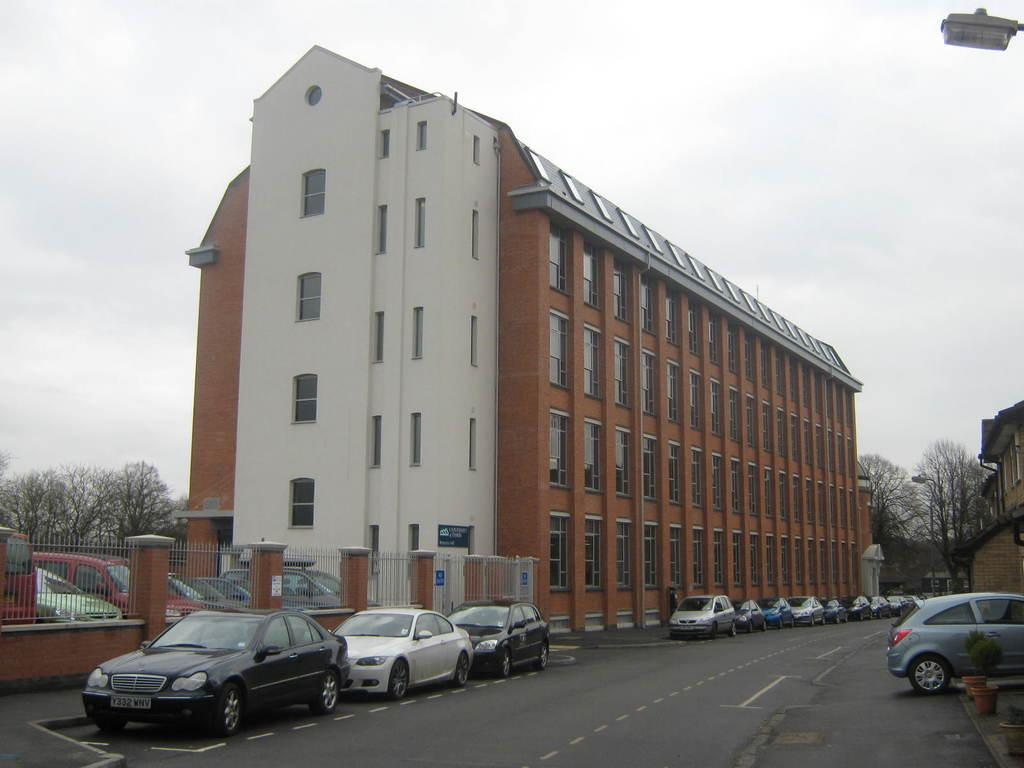What type of structures can be seen in the image? There are buildings in the image. What else can be seen in the image besides buildings? There are trees, cars parked on the side of the road, a pole light, and plants in pots in the image. How would you describe the sky in the image? The sky is blue and cloudy in the image. Where is the oven located in the image? There is no oven present in the image. Can you see any chickens in the image? There are no chickens present in the image. 